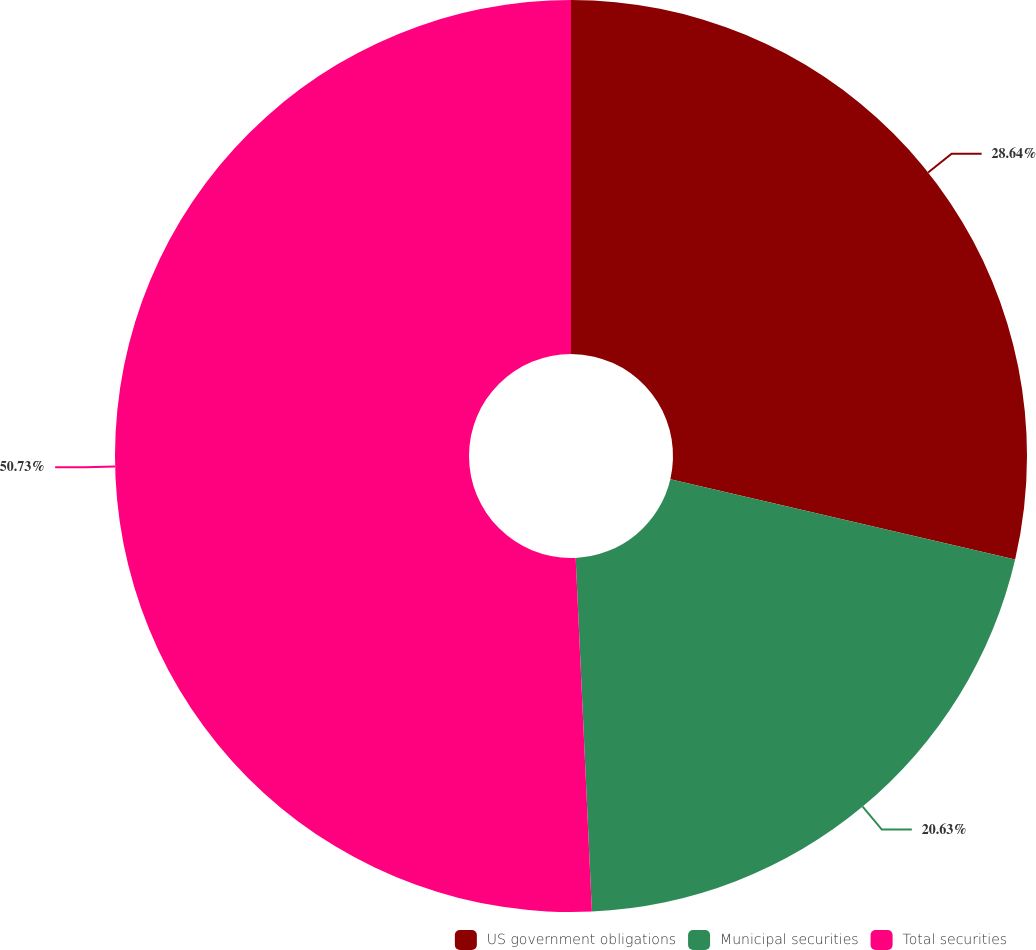Convert chart to OTSL. <chart><loc_0><loc_0><loc_500><loc_500><pie_chart><fcel>US government obligations<fcel>Municipal securities<fcel>Total securities<nl><fcel>28.64%<fcel>20.63%<fcel>50.73%<nl></chart> 